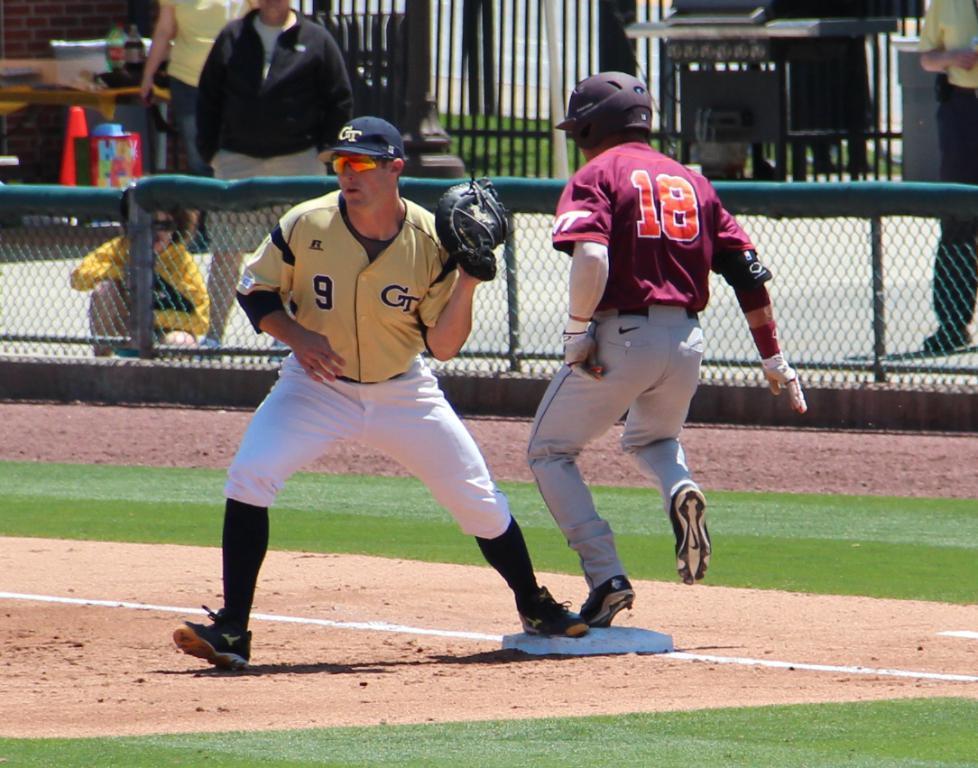In one or two sentences, can you explain what this image depicts? Front we can see two people. Background there is a mesh. people and table. On this table there are bottles. 